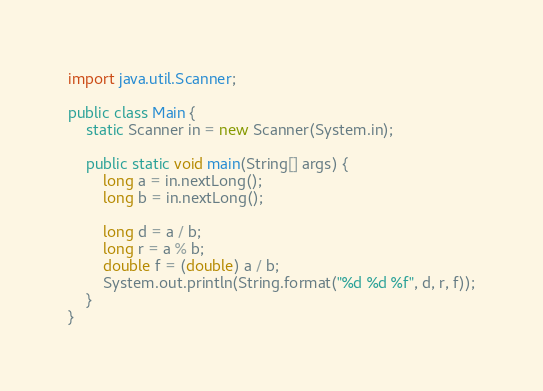<code> <loc_0><loc_0><loc_500><loc_500><_Java_>import java.util.Scanner;

public class Main {
	static Scanner in = new Scanner(System.in);

	public static void main(String[] args) {
		long a = in.nextLong();
		long b = in.nextLong();

		long d = a / b;
		long r = a % b;
		double f = (double) a / b;
		System.out.println(String.format("%d %d %f", d, r, f));
	}
}</code> 